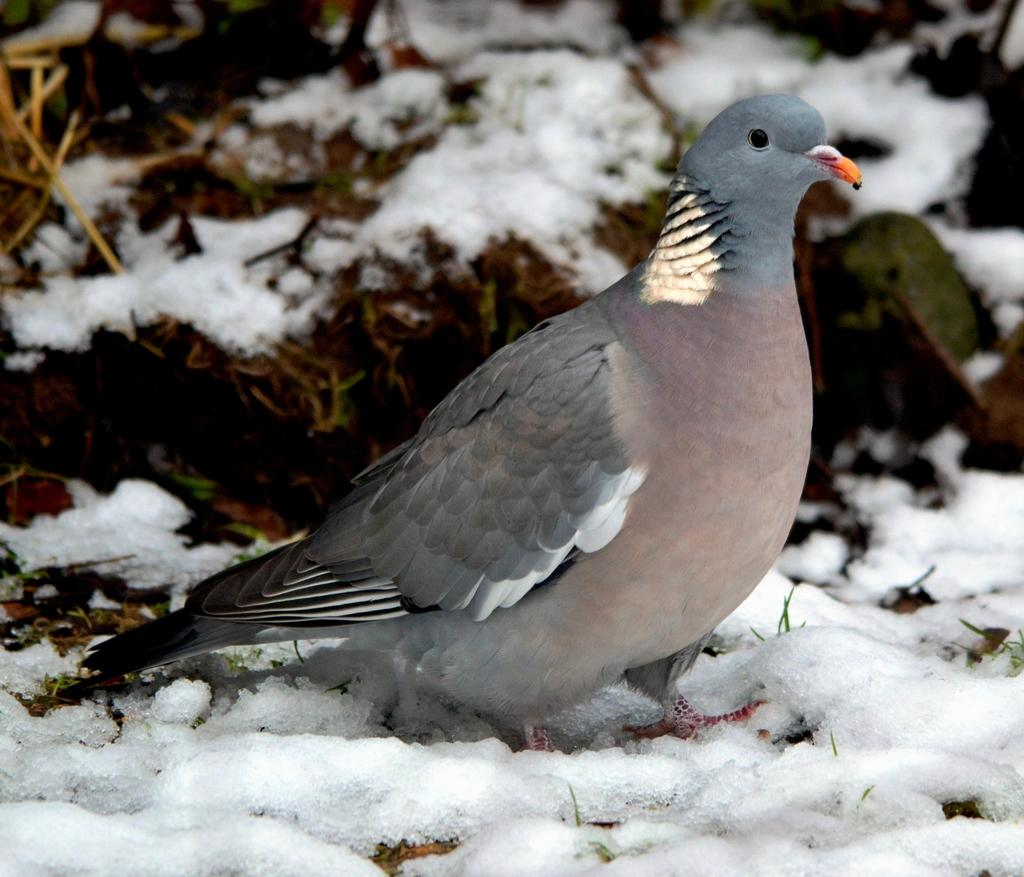What type of animal can be seen in the picture? There is a bird in the picture. What is the weather condition in the picture? There is snow in the picture. Can you describe the background of the picture? The background of the picture is blurry. What type of lipstick is the bird wearing in the picture? There is no lipstick or any indication of makeup on the bird in the picture. 